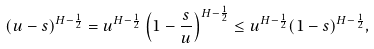<formula> <loc_0><loc_0><loc_500><loc_500>( u - s ) ^ { H - \frac { 1 } { 2 } } = u ^ { H - \frac { 1 } { 2 } } \left ( 1 - \frac { s } { u } \right ) ^ { H - \frac { 1 } { 2 } } \leq u ^ { H - \frac { 1 } { 2 } } ( 1 - s ) ^ { H - \frac { 1 } { 2 } } ,</formula> 